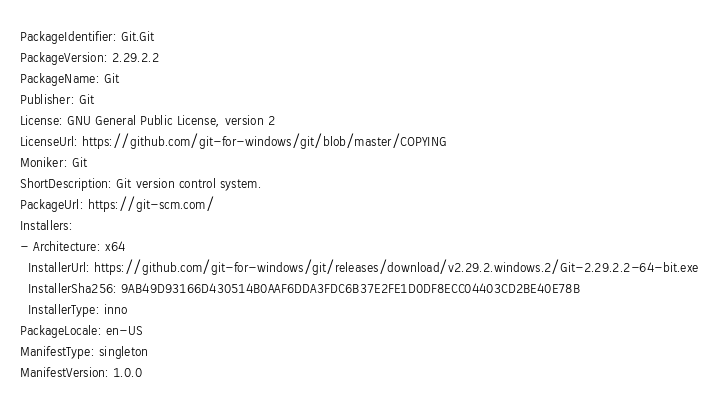Convert code to text. <code><loc_0><loc_0><loc_500><loc_500><_YAML_>PackageIdentifier: Git.Git
PackageVersion: 2.29.2.2
PackageName: Git
Publisher: Git
License: GNU General Public License, version 2
LicenseUrl: https://github.com/git-for-windows/git/blob/master/COPYING
Moniker: Git
ShortDescription: Git version control system.
PackageUrl: https://git-scm.com/
Installers:
- Architecture: x64
  InstallerUrl: https://github.com/git-for-windows/git/releases/download/v2.29.2.windows.2/Git-2.29.2.2-64-bit.exe
  InstallerSha256: 9AB49D93166D430514B0AAF6DDA3FDC6B37E2FE1D0DF8ECC04403CD2BE40E78B
  InstallerType: inno
PackageLocale: en-US
ManifestType: singleton
ManifestVersion: 1.0.0
</code> 